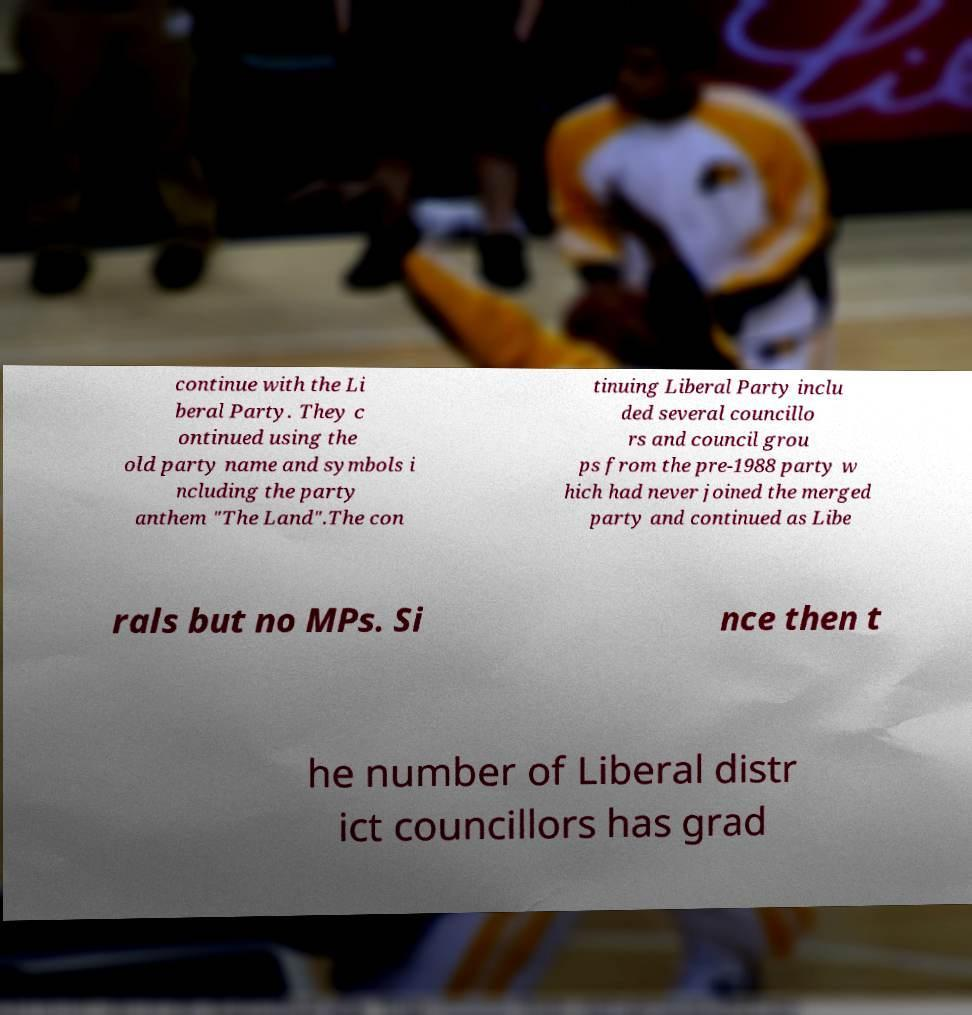There's text embedded in this image that I need extracted. Can you transcribe it verbatim? continue with the Li beral Party. They c ontinued using the old party name and symbols i ncluding the party anthem "The Land".The con tinuing Liberal Party inclu ded several councillo rs and council grou ps from the pre-1988 party w hich had never joined the merged party and continued as Libe rals but no MPs. Si nce then t he number of Liberal distr ict councillors has grad 